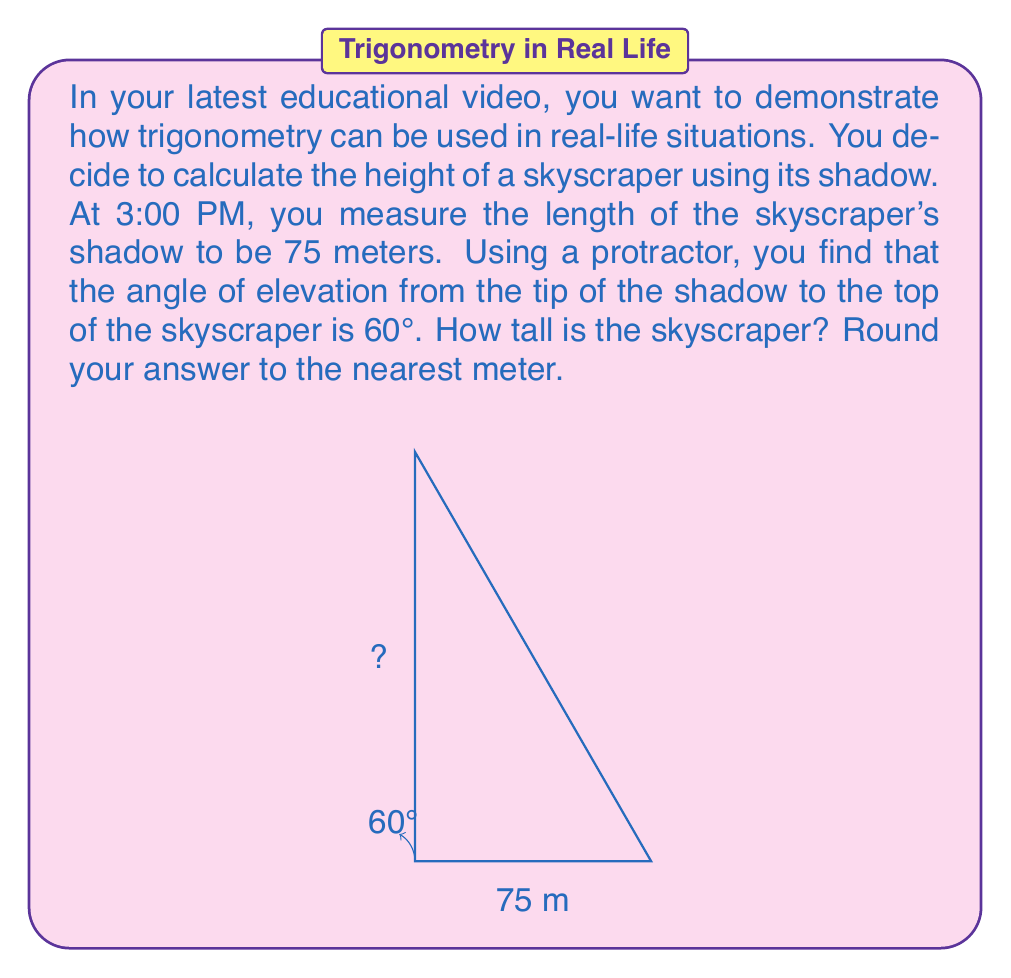Show me your answer to this math problem. Let's approach this step-by-step using trigonometry:

1) First, we need to identify which trigonometric ratio to use. We're given the angle of elevation and the length of the shadow (which is the adjacent side to this angle), and we need to find the height of the building (which is the opposite side to this angle). This scenario calls for the tangent ratio.

2) The tangent of an angle in a right triangle is defined as the ratio of the opposite side to the adjacent side:

   $$\tan \theta = \frac{\text{opposite}}{\text{adjacent}}$$

3) In our case:
   - $\theta = 60°$
   - adjacent = 75 meters (shadow length)
   - opposite = height of the building (what we're solving for)

4) Let's call the height of the building $h$. We can set up the equation:

   $$\tan 60° = \frac{h}{75}$$

5) To solve for $h$, we multiply both sides by 75:

   $$h = 75 \tan 60°$$

6) Now, we need to calculate this. $\tan 60° = \sqrt{3} \approx 1.732$

   $$h = 75 \times 1.732 = 129.9 \text{ meters}$$

7) Rounding to the nearest meter, we get 130 meters.
Answer: The skyscraper is approximately 130 meters tall. 